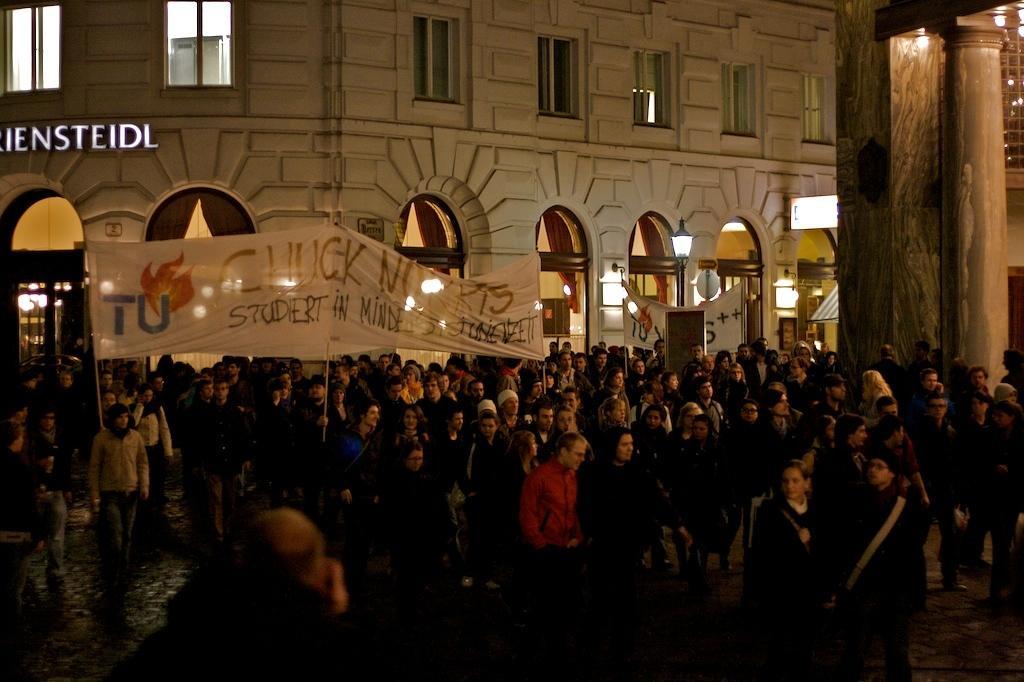Can you describe this image briefly? In this picture, there are people moving with the banners. On the banner, there is some text. In the center, there is a man wearing a red jacket. At the top, there is a building with windows. Towards the right, there are pillars. 